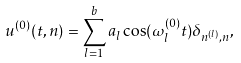<formula> <loc_0><loc_0><loc_500><loc_500>u ^ { ( 0 ) } ( t , n ) = \sum _ { l = 1 } ^ { b } a _ { l } \cos ( \omega _ { l } ^ { ( 0 ) } t ) \delta _ { n ^ { ( l ) } , n } ,</formula> 